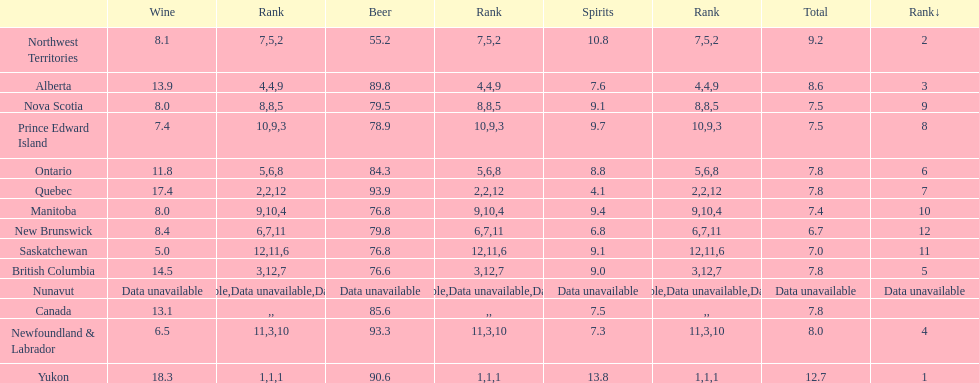How many litres do individuals in yukon consume in spirits per year? 12.7. 